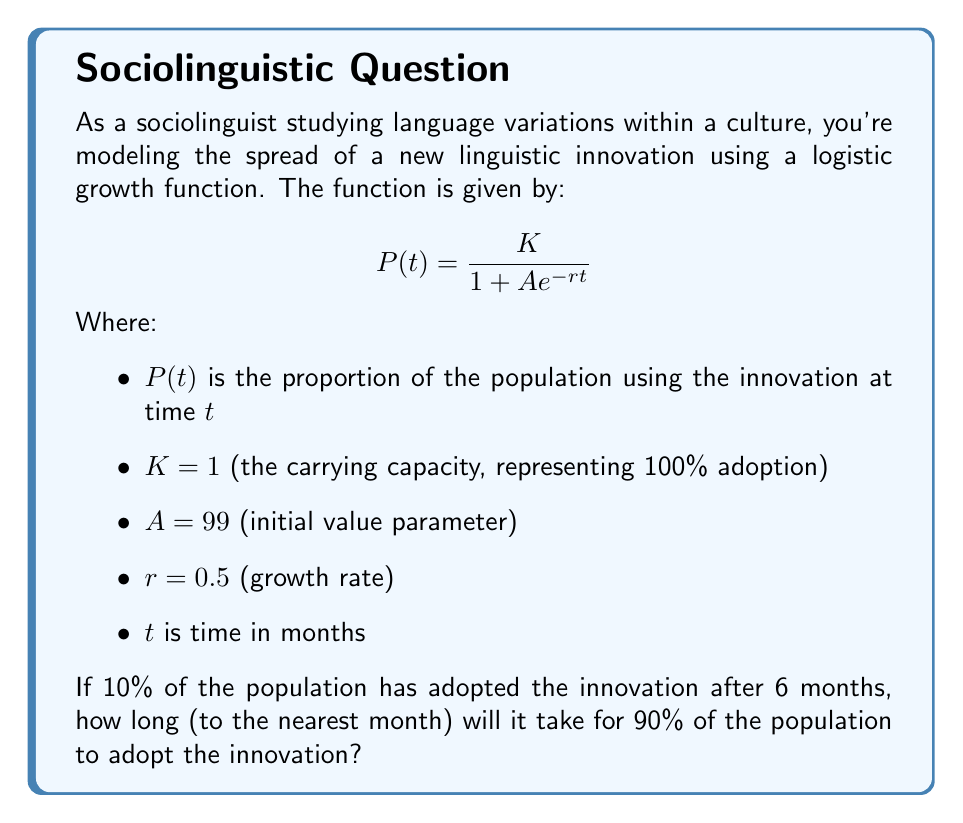Help me with this question. To solve this problem, we'll follow these steps:

1) First, we need to verify the given information at $t = 6$ months:

   $$P(6) = \frac{1}{1 + 99e^{-0.5(6)}} \approx 0.1003$$

   This confirms that approximately 10% of the population has adopted the innovation after 6 months.

2) Now, we need to find $t$ when $P(t) = 0.9$ (90% adoption):

   $$0.9 = \frac{1}{1 + 99e^{-0.5t}}$$

3) Solve this equation for $t$:

   $$1 + 99e^{-0.5t} = \frac{1}{0.9}$$
   
   $$99e^{-0.5t} = \frac{1}{0.9} - 1 = \frac{1}{9}$$
   
   $$e^{-0.5t} = \frac{1}{891}$$
   
   $$-0.5t = \ln(\frac{1}{891})$$
   
   $$t = -\frac{2\ln(\frac{1}{891})}{1} = 2\ln(891)$$

4) Calculate the value:

   $$t = 2\ln(891) \approx 13.57$$

5) Rounding to the nearest month:

   $t \approx 14$ months
Answer: It will take approximately 14 months for 90% of the population to adopt the linguistic innovation. 